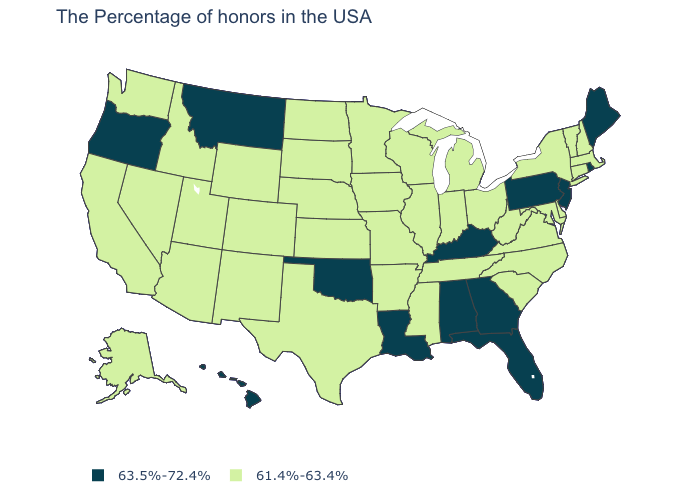Does Delaware have the highest value in the South?
Give a very brief answer. No. Does the first symbol in the legend represent the smallest category?
Concise answer only. No. Which states have the highest value in the USA?
Answer briefly. Maine, Rhode Island, New Jersey, Pennsylvania, Florida, Georgia, Kentucky, Alabama, Louisiana, Oklahoma, Montana, Oregon, Hawaii. Which states have the highest value in the USA?
Be succinct. Maine, Rhode Island, New Jersey, Pennsylvania, Florida, Georgia, Kentucky, Alabama, Louisiana, Oklahoma, Montana, Oregon, Hawaii. Name the states that have a value in the range 61.4%-63.4%?
Keep it brief. Massachusetts, New Hampshire, Vermont, Connecticut, New York, Delaware, Maryland, Virginia, North Carolina, South Carolina, West Virginia, Ohio, Michigan, Indiana, Tennessee, Wisconsin, Illinois, Mississippi, Missouri, Arkansas, Minnesota, Iowa, Kansas, Nebraska, Texas, South Dakota, North Dakota, Wyoming, Colorado, New Mexico, Utah, Arizona, Idaho, Nevada, California, Washington, Alaska. What is the lowest value in the USA?
Answer briefly. 61.4%-63.4%. Name the states that have a value in the range 63.5%-72.4%?
Concise answer only. Maine, Rhode Island, New Jersey, Pennsylvania, Florida, Georgia, Kentucky, Alabama, Louisiana, Oklahoma, Montana, Oregon, Hawaii. What is the value of Indiana?
Short answer required. 61.4%-63.4%. Name the states that have a value in the range 63.5%-72.4%?
Write a very short answer. Maine, Rhode Island, New Jersey, Pennsylvania, Florida, Georgia, Kentucky, Alabama, Louisiana, Oklahoma, Montana, Oregon, Hawaii. Name the states that have a value in the range 63.5%-72.4%?
Quick response, please. Maine, Rhode Island, New Jersey, Pennsylvania, Florida, Georgia, Kentucky, Alabama, Louisiana, Oklahoma, Montana, Oregon, Hawaii. Name the states that have a value in the range 63.5%-72.4%?
Answer briefly. Maine, Rhode Island, New Jersey, Pennsylvania, Florida, Georgia, Kentucky, Alabama, Louisiana, Oklahoma, Montana, Oregon, Hawaii. What is the lowest value in the USA?
Be succinct. 61.4%-63.4%. Does New Mexico have the same value as Minnesota?
Give a very brief answer. Yes. What is the value of New Jersey?
Quick response, please. 63.5%-72.4%. What is the lowest value in states that border Massachusetts?
Be succinct. 61.4%-63.4%. 